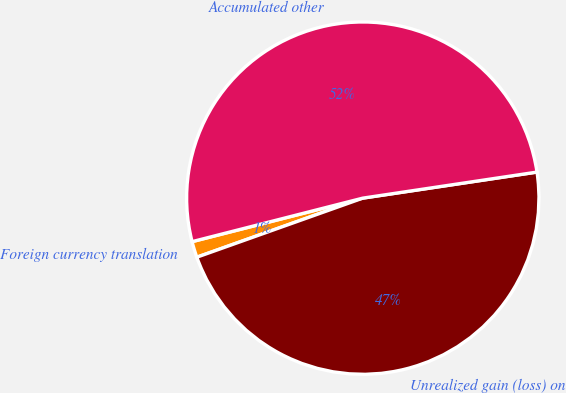<chart> <loc_0><loc_0><loc_500><loc_500><pie_chart><fcel>Foreign currency translation<fcel>Unrealized gain (loss) on<fcel>Accumulated other<nl><fcel>1.47%<fcel>46.92%<fcel>51.61%<nl></chart> 